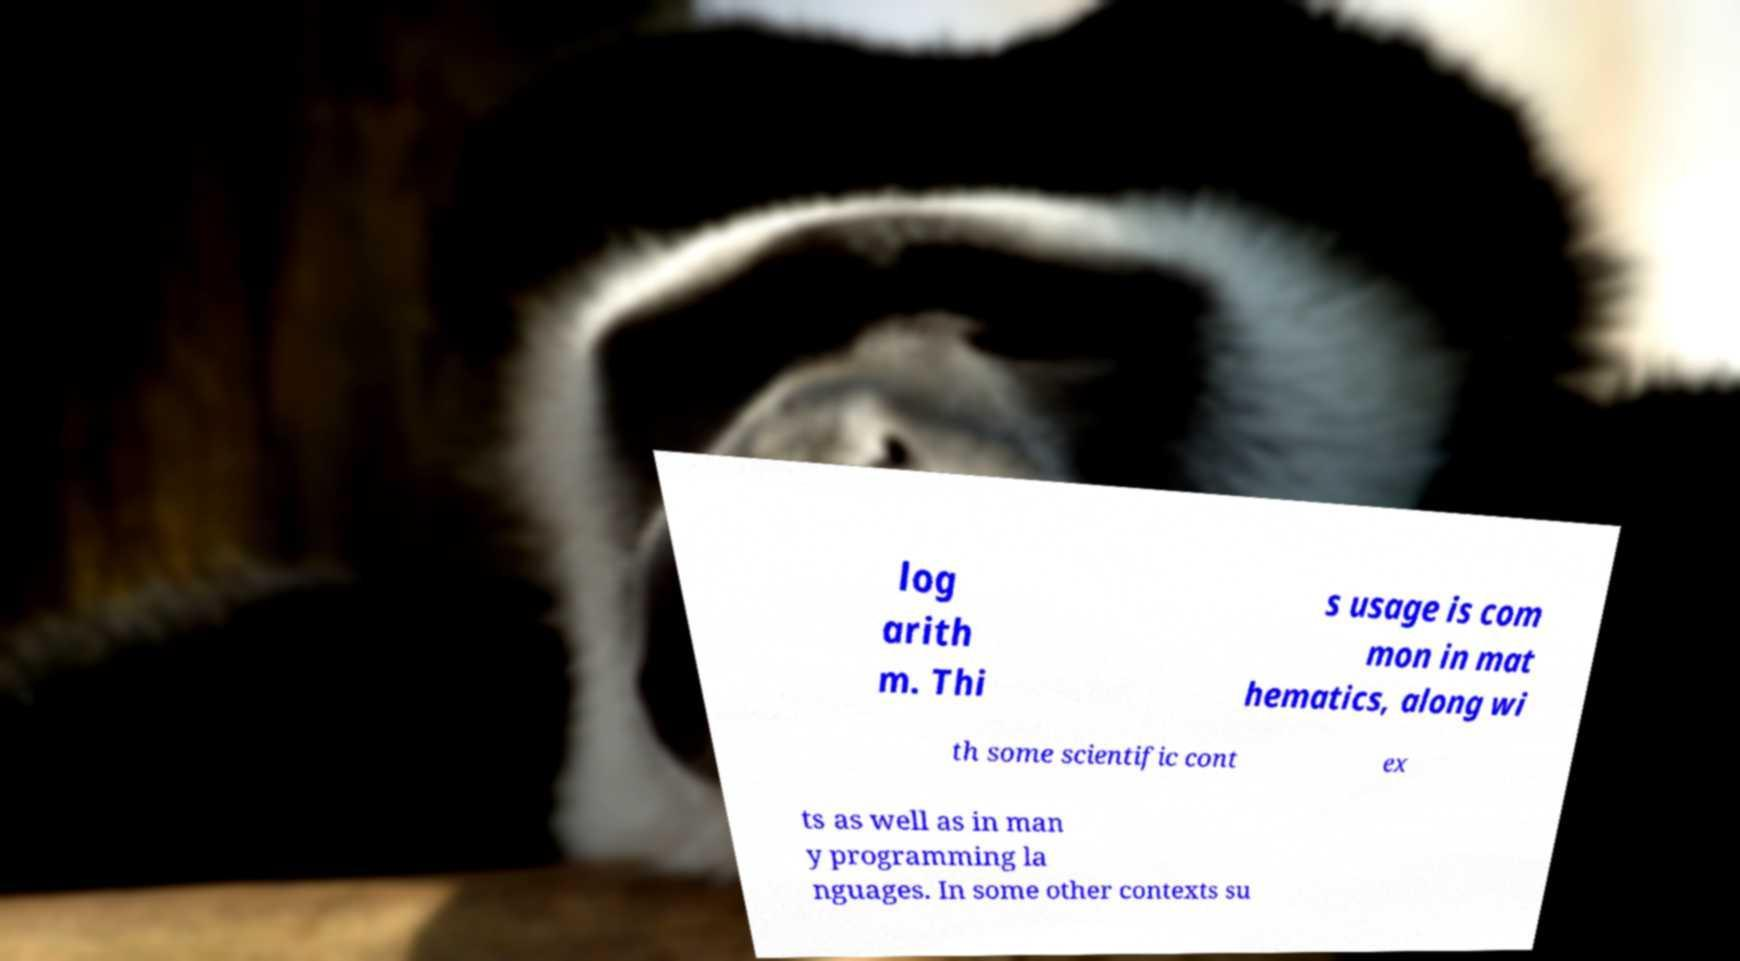I need the written content from this picture converted into text. Can you do that? log arith m. Thi s usage is com mon in mat hematics, along wi th some scientific cont ex ts as well as in man y programming la nguages. In some other contexts su 